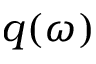<formula> <loc_0><loc_0><loc_500><loc_500>q ( \omega )</formula> 